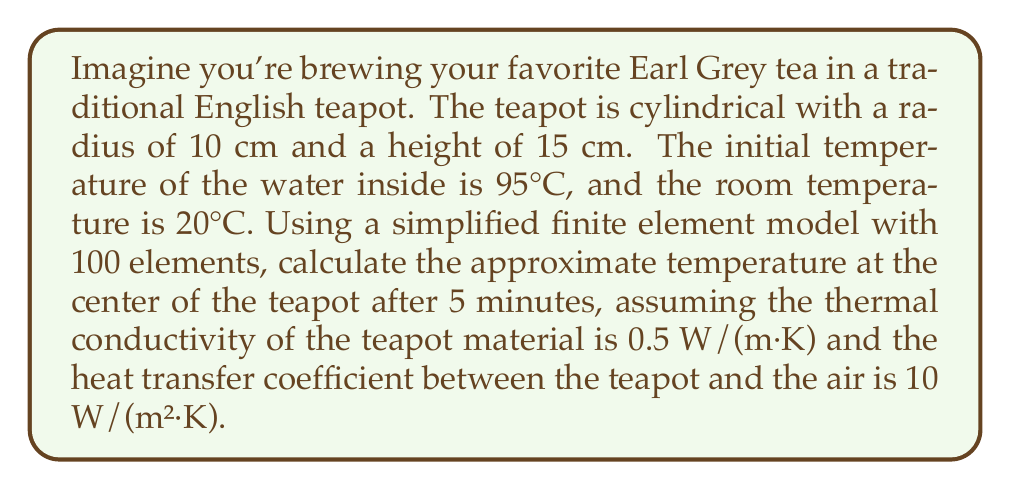What is the answer to this math problem? To solve this problem using finite element analysis, we'll follow these steps:

1. Set up the heat equation:
   The heat equation in cylindrical coordinates is:
   $$\frac{\partial T}{\partial t} = \alpha \left(\frac{\partial^2 T}{\partial r^2} + \frac{1}{r}\frac{\partial T}{\partial r} + \frac{\partial^2 T}{\partial z^2}\right)$$
   where $\alpha$ is the thermal diffusivity.

2. Define boundary conditions:
   - Initial condition: $T(r,z,0) = 95°C$
   - Boundary condition: $-k\frac{\partial T}{\partial n} = h(T - T_{\text{room}})$
     where $k$ is thermal conductivity, $h$ is heat transfer coefficient, and $n$ is the normal direction.

3. Discretize the domain:
   With 100 elements, we can use a 10x10 grid in the r-z plane.

4. Apply the finite element method:
   Use linear shape functions and the Galerkin method to discretize the heat equation in space and time.

5. Solve the resulting system of equations:
   Use an implicit time-stepping scheme (e.g., backward Euler) to solve for the temperature distribution over time.

6. Extract the temperature at the center:
   The center corresponds to $r=0$ and $z=7.5$ cm.

For a simplified calculation, we can use the lumped capacitance method as an approximation:

1. Calculate the Biot number:
   $$Bi = \frac{hL_c}{k} = \frac{10 \cdot 0.05}{0.5} = 1$$
   where $L_c$ is the characteristic length (volume/surface area).

2. Since $Bi = 1$, the lumped capacitance method is not ideal but can give a rough estimate.

3. Use the equation:
   $$T(t) = T_{\text{room}} + (T_{\text{initial}} - T_{\text{room}})e^{-\beta t}$$
   where $\beta = \frac{hA}{\rho V c_p}$

4. Estimate $\beta$:
   Assume $\rho \approx 1000$ kg/m³, $c_p \approx 4200$ J/(kg·K)
   $A = 2\pi r^2 + 2\pi rh \approx 0.157$ m²
   $V = \pi r^2 h \approx 0.00471$ m³
   $$\beta \approx \frac{10 \cdot 0.157}{1000 \cdot 0.00471 \cdot 4200} \approx 0.000792 \text{ s}^{-1}$$

5. Calculate the temperature after 5 minutes (300 seconds):
   $$T(300) = 20 + (95 - 20)e^{-0.000792 \cdot 300} \approx 73.8°C$$

This simplified method gives an approximate result. A full finite element analysis would provide a more accurate solution, especially for the temperature distribution within the teapot.
Answer: The approximate temperature at the center of the teapot after 5 minutes is 73.8°C. 